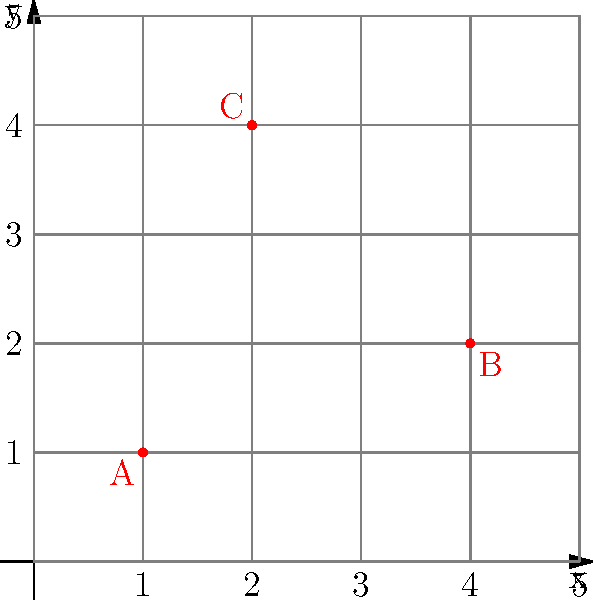In a warehouse layout represented by a 5x5 grid, three fire extinguishers (A, B, and C) are placed as shown in the diagram. What are the coordinates of the fire extinguisher that is closest to the point (3,3) on the grid? To find the fire extinguisher closest to the point (3,3), we need to calculate the distance between each fire extinguisher and the point (3,3) using the distance formula:

$d = \sqrt{(x_2-x_1)^2 + (y_2-y_1)^2}$

1. Calculate the distance for extinguisher A (1,1):
   $d_A = \sqrt{(3-1)^2 + (3-1)^2} = \sqrt{4 + 4} = \sqrt{8} \approx 2.83$

2. Calculate the distance for extinguisher B (4,2):
   $d_B = \sqrt{(3-4)^2 + (3-2)^2} = \sqrt{1 + 1} = \sqrt{2} \approx 1.41$

3. Calculate the distance for extinguisher C (2,4):
   $d_C = \sqrt{(3-2)^2 + (3-4)^2} = \sqrt{1 + 1} = \sqrt{2} \approx 1.41$

Comparing the distances:
$d_B = d_C < d_A$

Both B and C are equally close to (3,3), but the question asks for the coordinates of the closest extinguisher. Since B and C are equidistant, we can choose either one. Let's select B.
Answer: (4,2) 